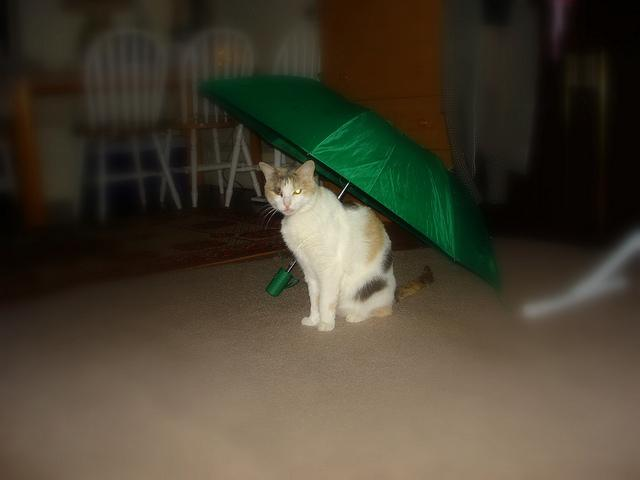What object used to prevent getting wet is nearby the cat in this image? umbrella 